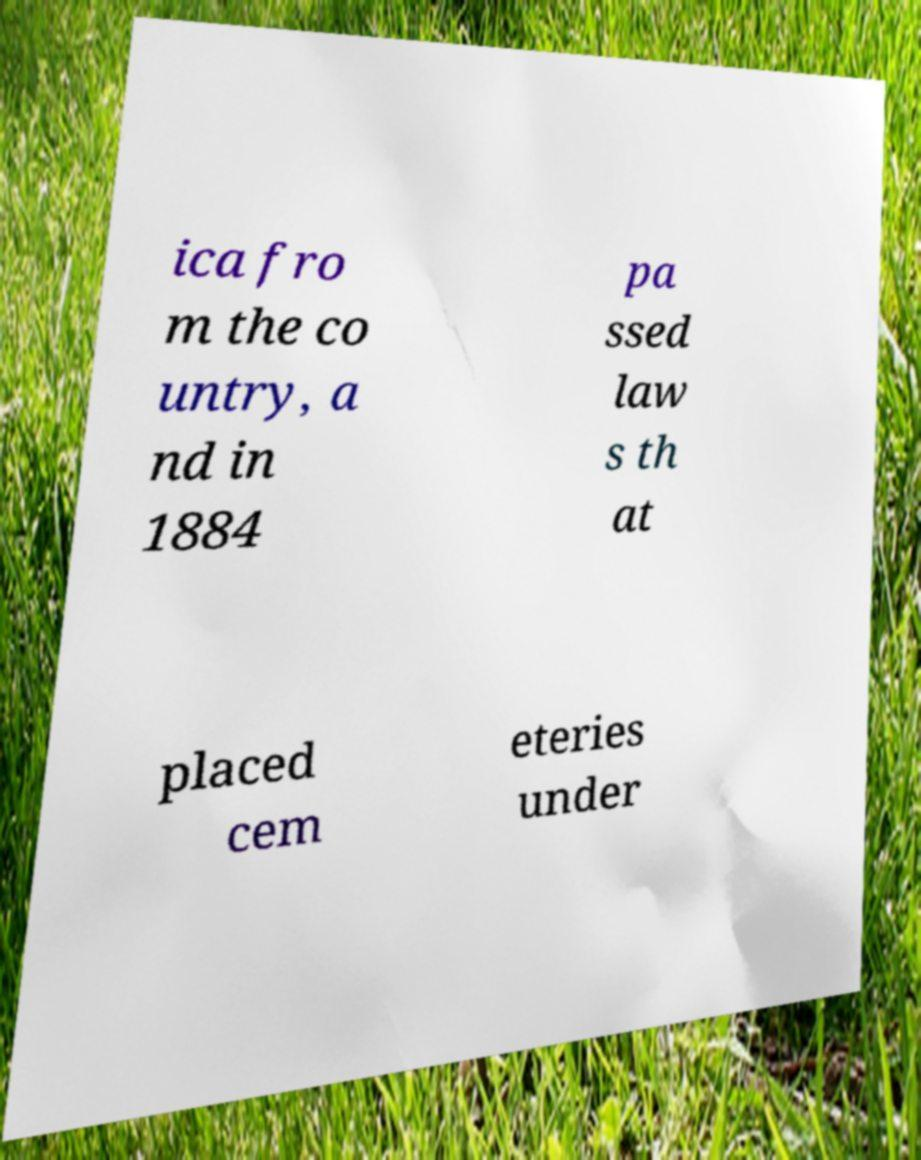Please identify and transcribe the text found in this image. ica fro m the co untry, a nd in 1884 pa ssed law s th at placed cem eteries under 